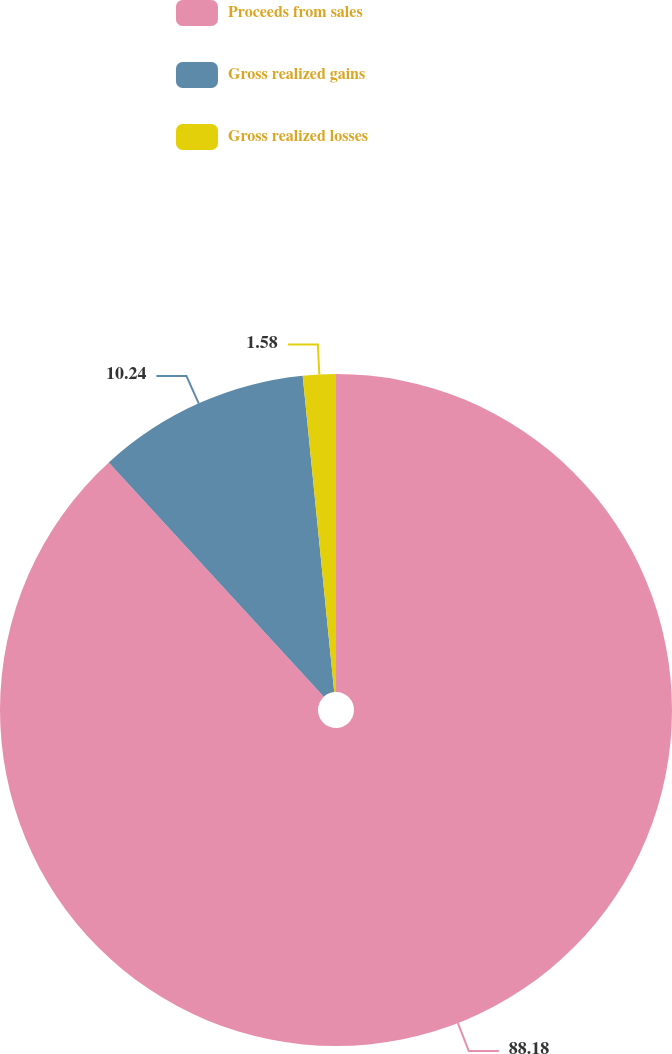Convert chart. <chart><loc_0><loc_0><loc_500><loc_500><pie_chart><fcel>Proceeds from sales<fcel>Gross realized gains<fcel>Gross realized losses<nl><fcel>88.17%<fcel>10.24%<fcel>1.58%<nl></chart> 